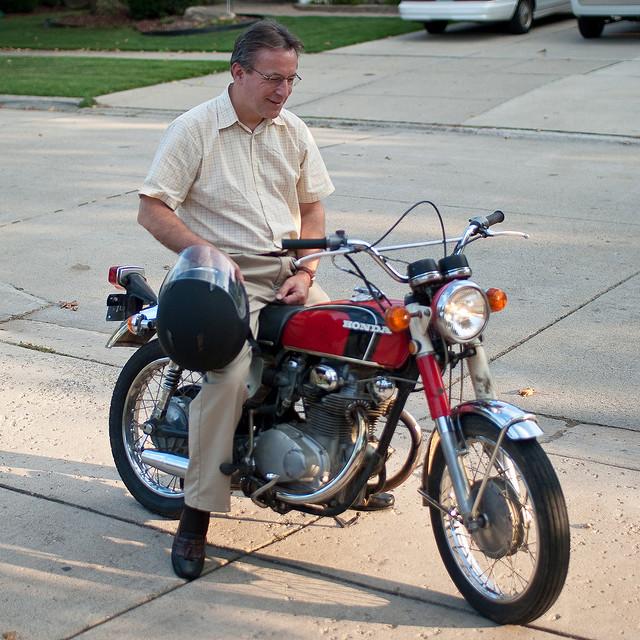Is the motorcycle in motion?
Short answer required. No. Who is on the bike?
Keep it brief. Man. Is he wearing a helmet?
Answer briefly. No. What color are the man's clothes?
Short answer required. Tan. What job does this man have?
Be succinct. Office worker. 